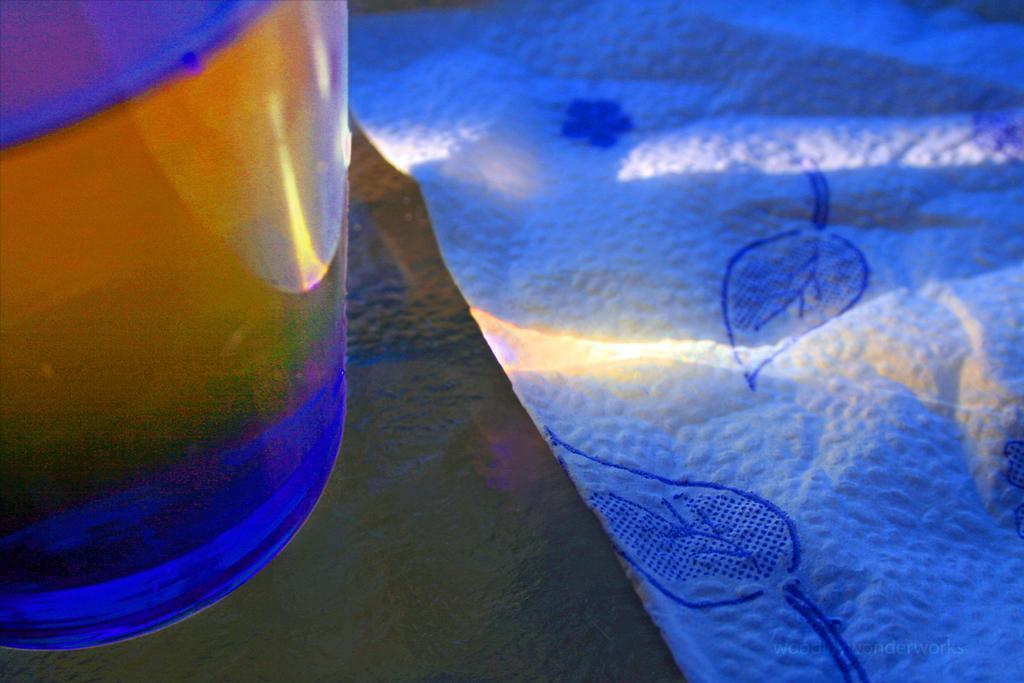Describe this image in one or two sentences. On the left side of the image, we can see a glass object on the black surface. Here we can see a cloth. On the right side bottom of the image, there is a watermark in the image. 